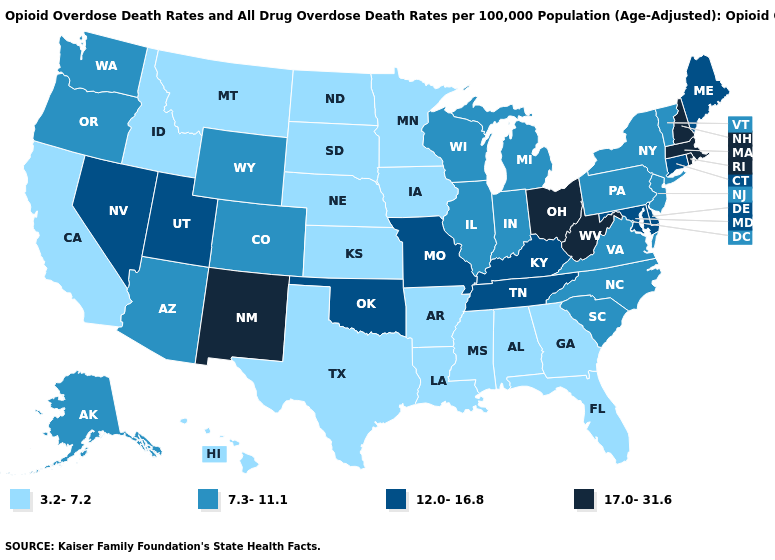Which states have the lowest value in the Northeast?
Keep it brief. New Jersey, New York, Pennsylvania, Vermont. Name the states that have a value in the range 7.3-11.1?
Short answer required. Alaska, Arizona, Colorado, Illinois, Indiana, Michigan, New Jersey, New York, North Carolina, Oregon, Pennsylvania, South Carolina, Vermont, Virginia, Washington, Wisconsin, Wyoming. Is the legend a continuous bar?
Quick response, please. No. What is the highest value in the Northeast ?
Give a very brief answer. 17.0-31.6. Which states hav the highest value in the West?
Answer briefly. New Mexico. What is the highest value in the USA?
Short answer required. 17.0-31.6. Does Maryland have the same value as Maine?
Quick response, please. Yes. Does Iowa have a lower value than Idaho?
Quick response, please. No. How many symbols are there in the legend?
Write a very short answer. 4. What is the lowest value in the USA?
Keep it brief. 3.2-7.2. Does West Virginia have the highest value in the South?
Write a very short answer. Yes. What is the highest value in the Northeast ?
Give a very brief answer. 17.0-31.6. What is the value of Oklahoma?
Be succinct. 12.0-16.8. Name the states that have a value in the range 12.0-16.8?
Short answer required. Connecticut, Delaware, Kentucky, Maine, Maryland, Missouri, Nevada, Oklahoma, Tennessee, Utah. 